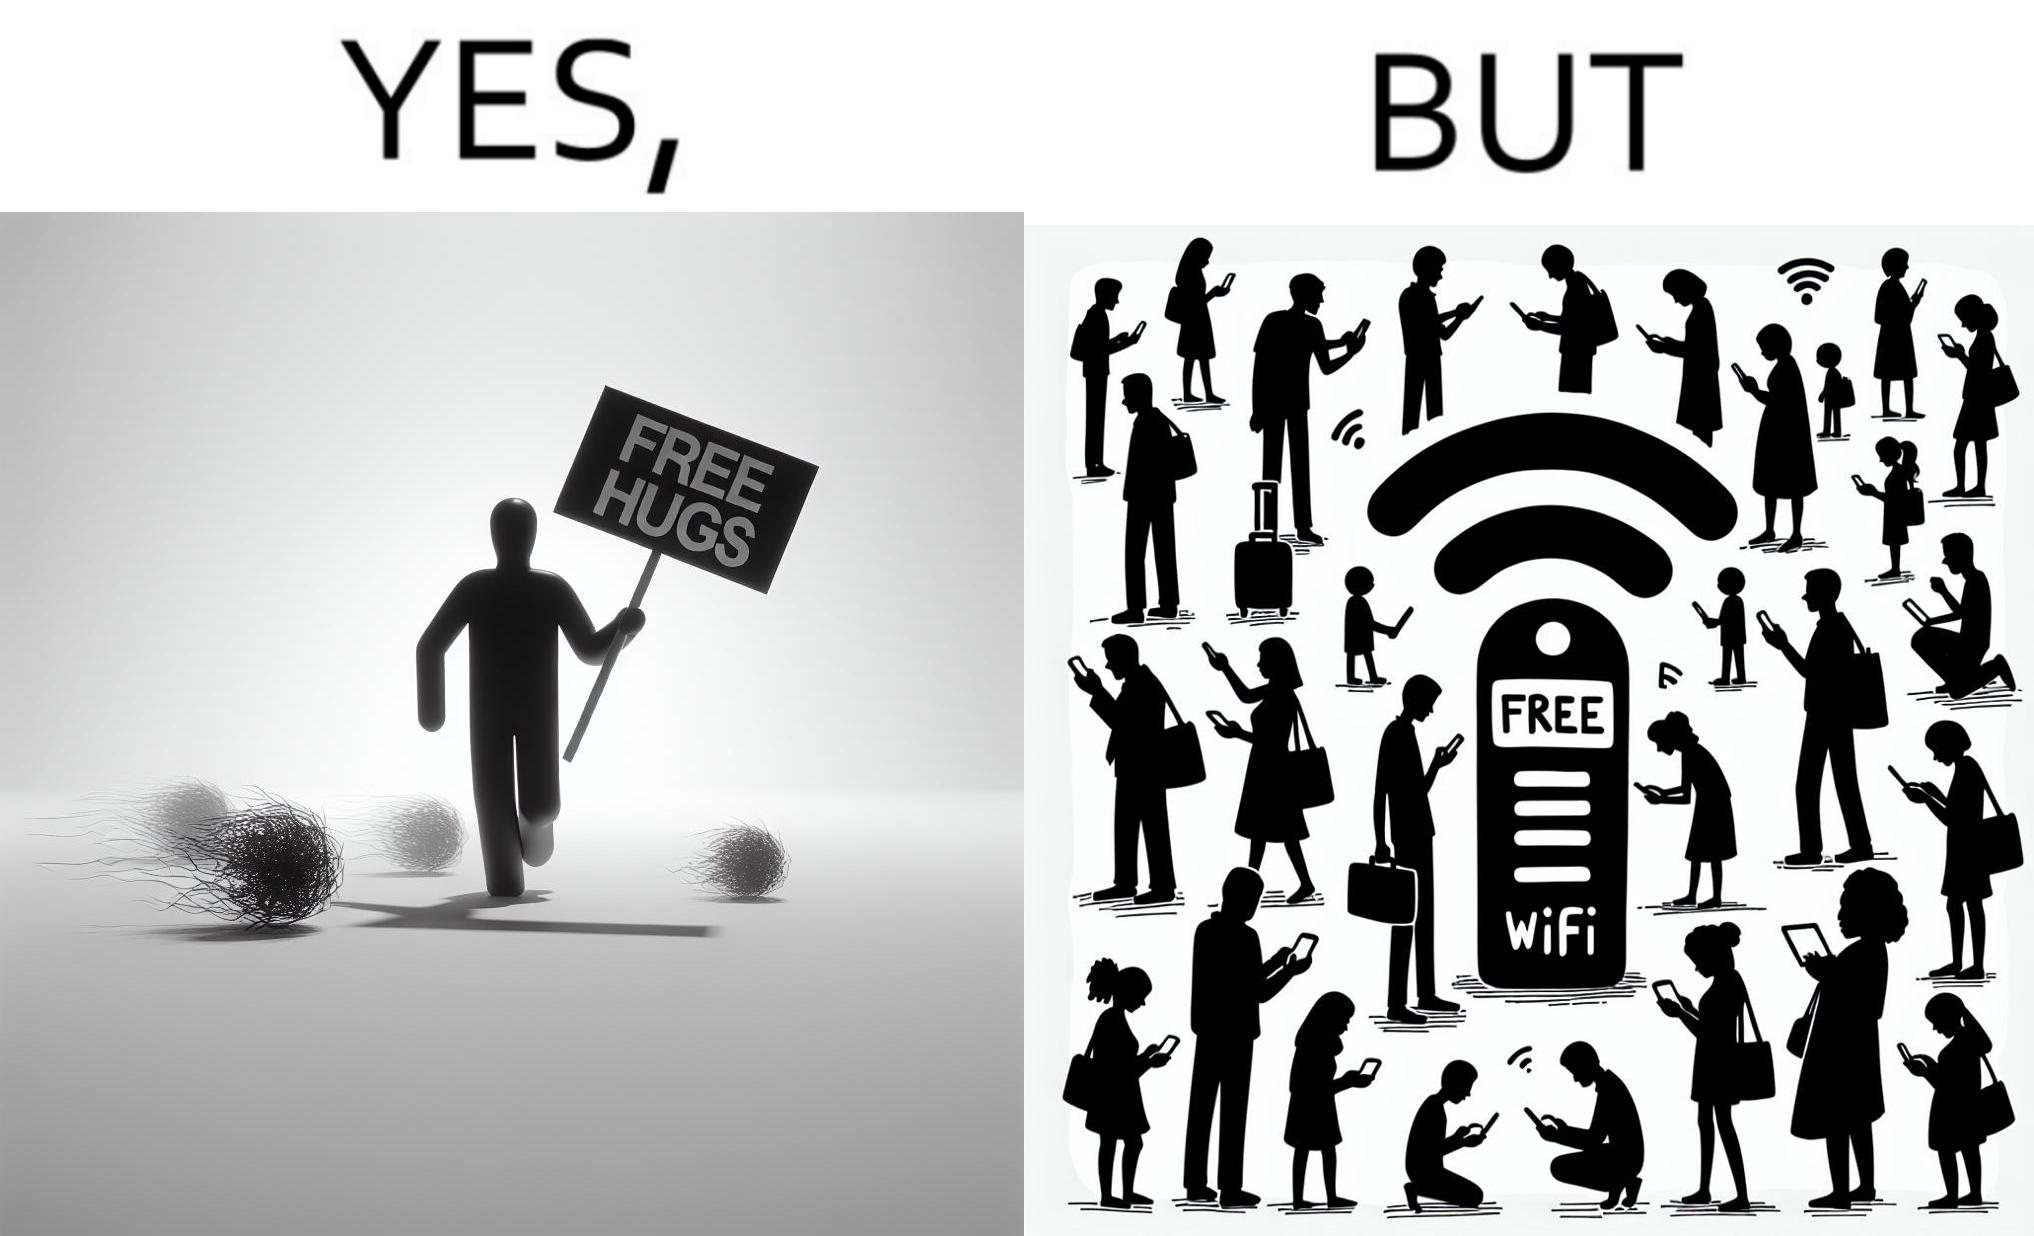What do you see in each half of this image? In the left part of the image: a person standing alone holding a sign "Free Hugs". The tumbleweeds blowing in the wind further stress on the loneliness. In the right part of the image: A Wi-fi Router with the label "Free Wifi" in front of it, surrounded by people trying to connect to it on their mobile devices. 